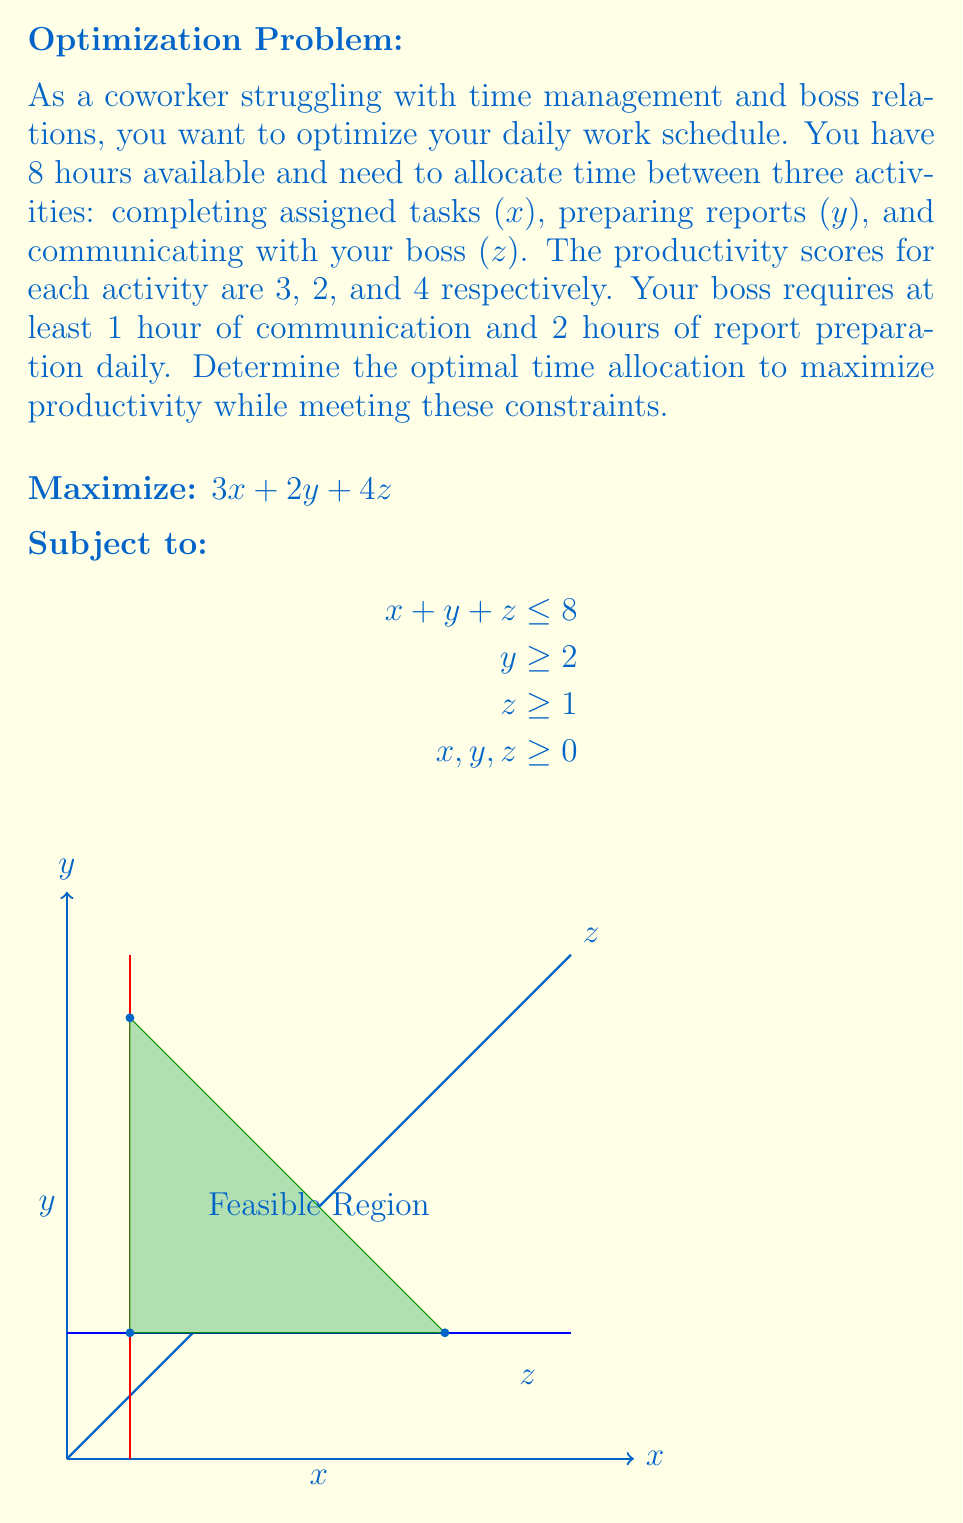Teach me how to tackle this problem. To solve this linear programming problem, we'll use the graphical method:

1) Plot the constraints:
   - $x + y + z = 8$ (our budget line)
   - $y = 2$ (minimum report preparation time)
   - $z = 1$ (minimum communication time)

2) Identify the feasible region (shaded in green in the diagram).

3) Find the corner points of the feasible region:
   A(1, 2, 5), B(5, 2, 1), C(1, 6, 1)

4) Evaluate the objective function at each corner point:
   A: $3(1) + 2(2) + 4(5) = 25$
   B: $3(5) + 2(2) + 4(1) = 21$
   C: $3(1) + 2(6) + 4(1) = 19$

5) The maximum value occurs at point A(1, 2, 5), which represents:
   - 1 hour on assigned tasks (x)
   - 2 hours on report preparation (y)
   - 5 hours on communication with the boss (z)

This allocation maximizes productivity while meeting all constraints.
Answer: Optimal allocation: (1, 2, 5) hours for tasks, reports, and communication respectively. 